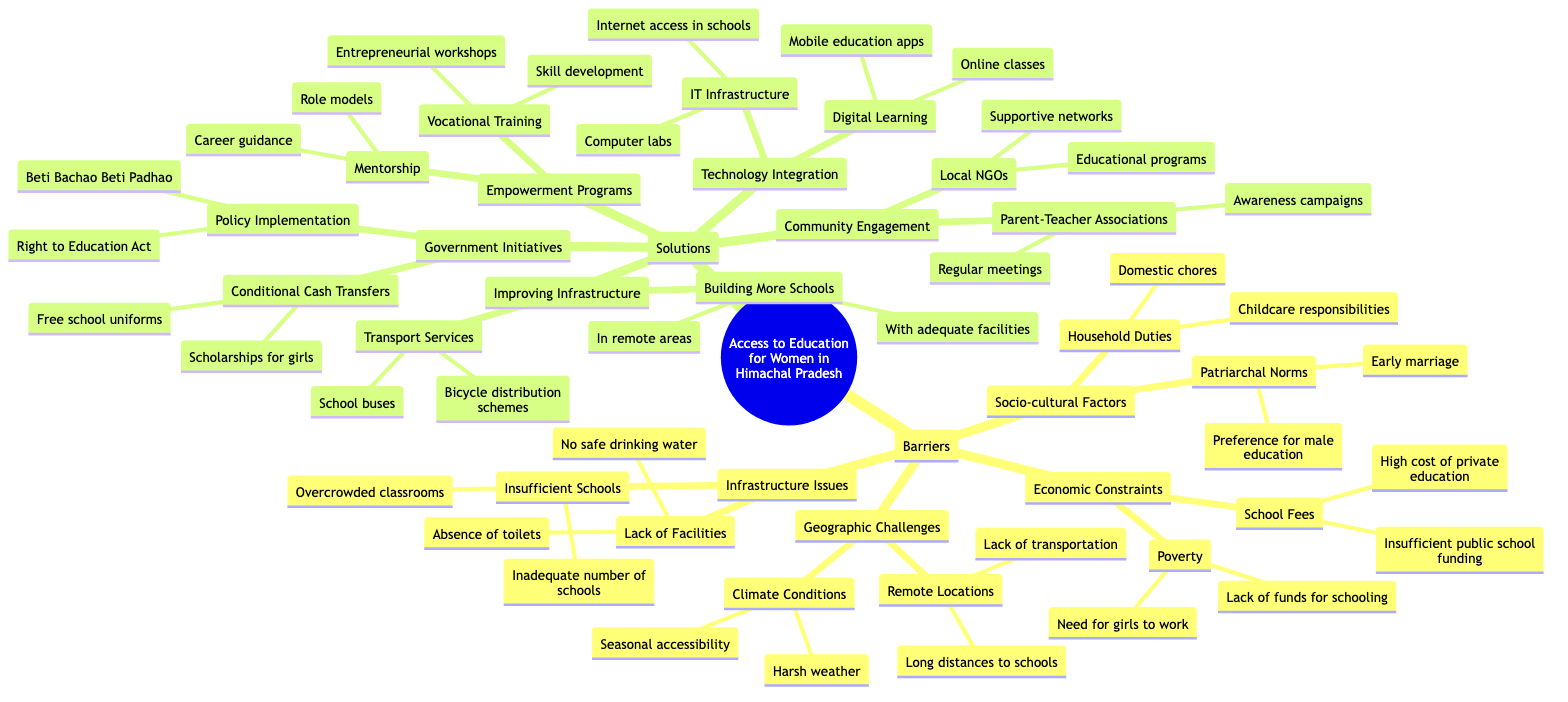What are the socio-cultural factors that hinder women's education in Himachal Pradesh? The diagram highlights two main socio-cultural factors: Patriarchal Norms and Household Duties. Under Patriarchal Norms, we see issues like preference for male education and early marriage. Under Household Duties, the responsibilities include domestic chores and childcare. By referencing the "Barriers" section, we connect these factors directly impacting women's education.
Answer: Patriarchal Norms, Household Duties How many types of barriers to women's education are identified in the diagram? The diagram categorizes barriers into four main types: Socio-cultural Factors, Economic Constraints, Geographic Challenges, and Infrastructure Issues. By counting these categories, we find the total number of distinct barrier types.
Answer: 4 What is one solution provided for improving infrastructure related to women's education? Looking at the "Solutions" section, one specific solution under "Improving Infrastructure" is "Building More Schools." This entails two actions: building in remote areas and ensuring schools have adequate facilities. This direct reference to the content provides clarity on infrastructure improvement efforts.
Answer: Building More Schools Which government initiative focuses specifically on financial support for girls' education? The diagram lists "Conditional Cash Transfers" under Government Initiatives, which includes scholarships for girls and free school uniforms as part of its strategies. This direct piece of information from the solutions highlights a financial support mechanism specifically aimed at girls' education.
Answer: Conditional Cash Transfers What role do Local NGOs play in addressing barriers to women's education? According to the "Solutions" section, Local NGOs are associated with providing educational programs and supportive networks. This information points to their contribution in engaging the community and developing programs that facilitate access to education for women.
Answer: Educational programs, Supportive networks What kind of empowerment programs are mentioned in the diagram? The diagram outlines two main types of empowerment programs: Vocational Training and Mentorship. Vocational Training includes skill development and entrepreneurial workshops, while Mentorship involves role models and career guidance. This summary of the empowerment programs illustrates their purpose in supporting women's education.
Answer: Vocational Training, Mentorship How does the diagram suggest addressing economic constraints in women's education? One key approach noted under "Economic Constraints" in the "Solutions" section is Government Initiatives, specifically through Conditional Cash Transfers, which offer scholarships for girls and free school uniforms. This shows a targeted effort to alleviate financial barriers hindering women's education.
Answer: Conditional Cash Transfers What technology integration method is proposed to enhance women's education access? The solutions outlined in the diagram include "Digital Learning," which features online classes and mobile education apps. This indicates an approach to leverage technology in making education more accessible and flexible for women and girls.
Answer: Digital Learning 